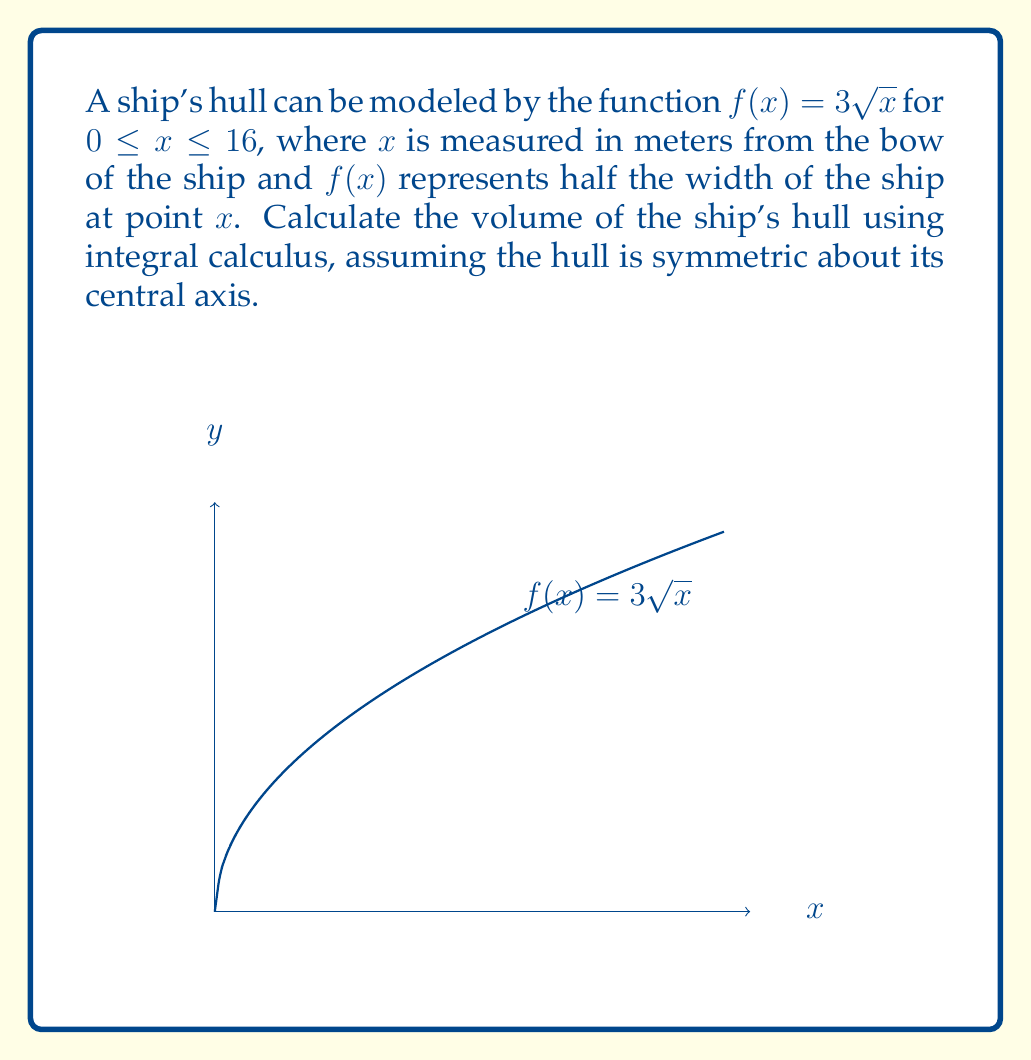Teach me how to tackle this problem. To calculate the volume of the ship's hull, we need to use the disk method of integration. Since the hull is symmetric, we'll integrate the area of circular cross-sections along the length of the ship.

1) The area of each circular cross-section is given by $A(x) = \pi r^2$, where $r$ is the radius. In this case, $r = f(x) = 3\sqrt{x}$.

2) Therefore, the area of each cross-section is:
   $A(x) = \pi (3\sqrt{x})^2 = 9\pi x$

3) The volume of the hull can be calculated by integrating this area over the length of the ship:

   $$V = \int_0^{16} A(x) dx = \int_0^{16} 9\pi x dx$$

4) Solving the integral:
   $$V = 9\pi \int_0^{16} x dx = 9\pi [\frac{1}{2}x^2]_0^{16}$$

5) Evaluating the integral:
   $$V = 9\pi (\frac{1}{2}(16)^2 - \frac{1}{2}(0)^2) = 9\pi (128 - 0) = 1152\pi$$

6) The volume is in cubic meters, so our final answer is $1152\pi$ m³.
Answer: $1152\pi$ cubic meters 